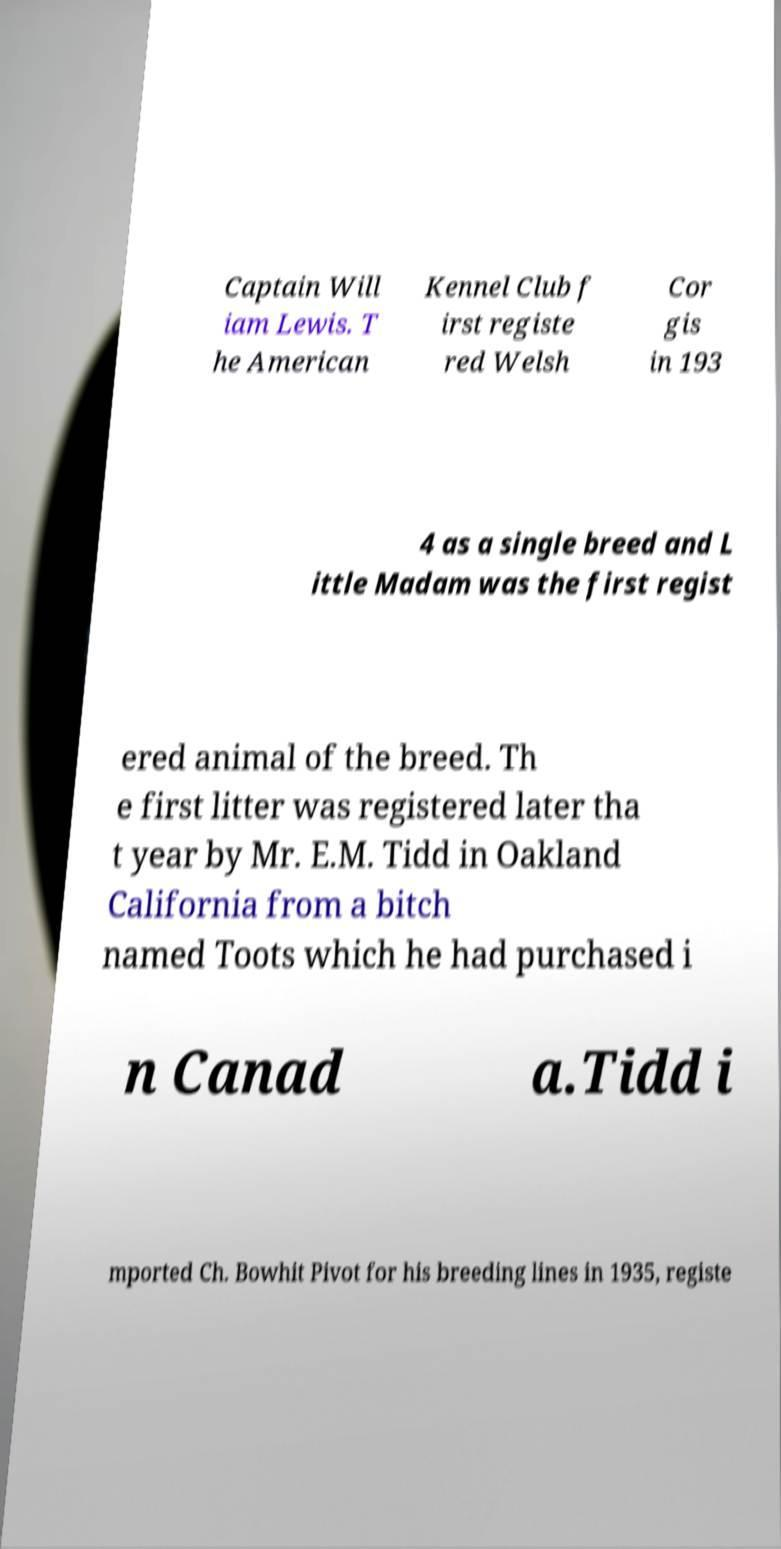Please identify and transcribe the text found in this image. Captain Will iam Lewis. T he American Kennel Club f irst registe red Welsh Cor gis in 193 4 as a single breed and L ittle Madam was the first regist ered animal of the breed. Th e first litter was registered later tha t year by Mr. E.M. Tidd in Oakland California from a bitch named Toots which he had purchased i n Canad a.Tidd i mported Ch. Bowhit Pivot for his breeding lines in 1935, registe 